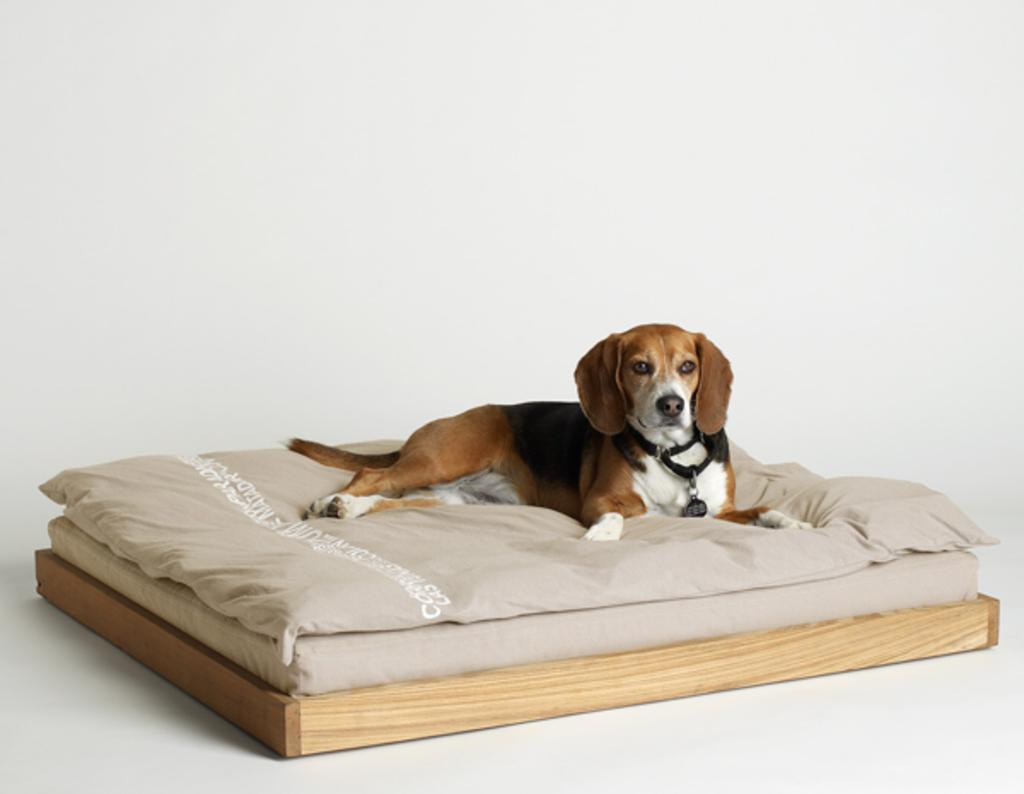What type of animal can be seen in the image? There is a dog in the image. What is the dog doing in the image? The dog is laying on the bed. What is under the bed in the image? There is a wooden plank under the bed. What color is the background of the image? The background of the image is in white color. What type of breakfast is the dog eating in the image? There is no breakfast present in the image; the dog is laying on the bed. How does the ladybug feel about the dog in the image? There is no ladybug present in the image, so it is impossible to determine its feelings. 